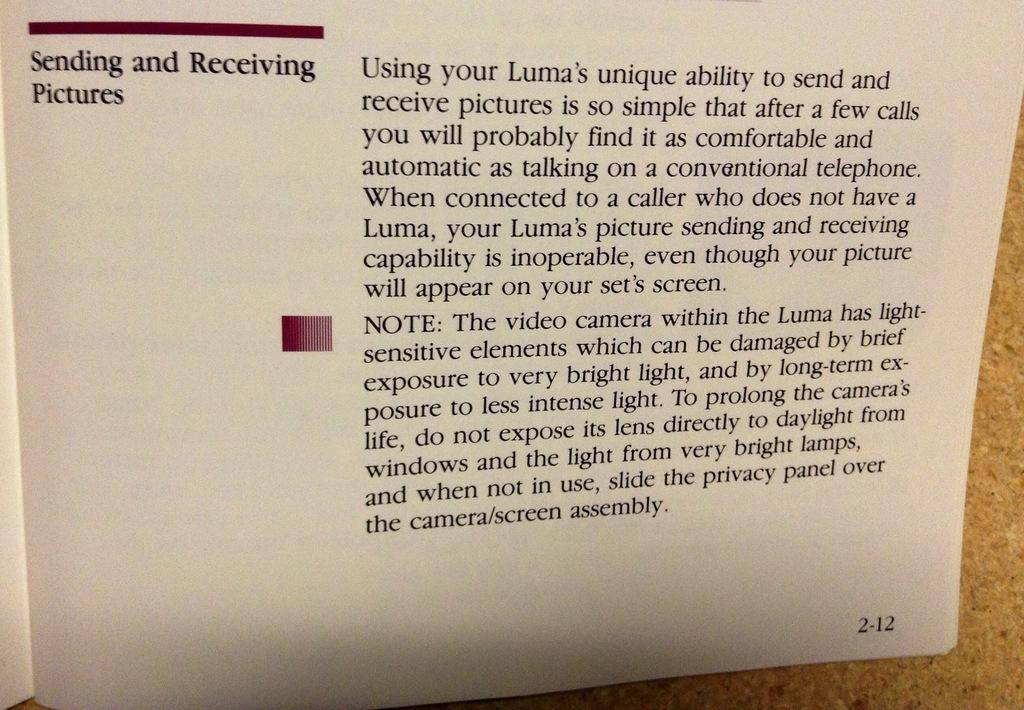<image>
Create a compact narrative representing the image presented. A user guide for sending and receiving pictures on a Luma is opened. 